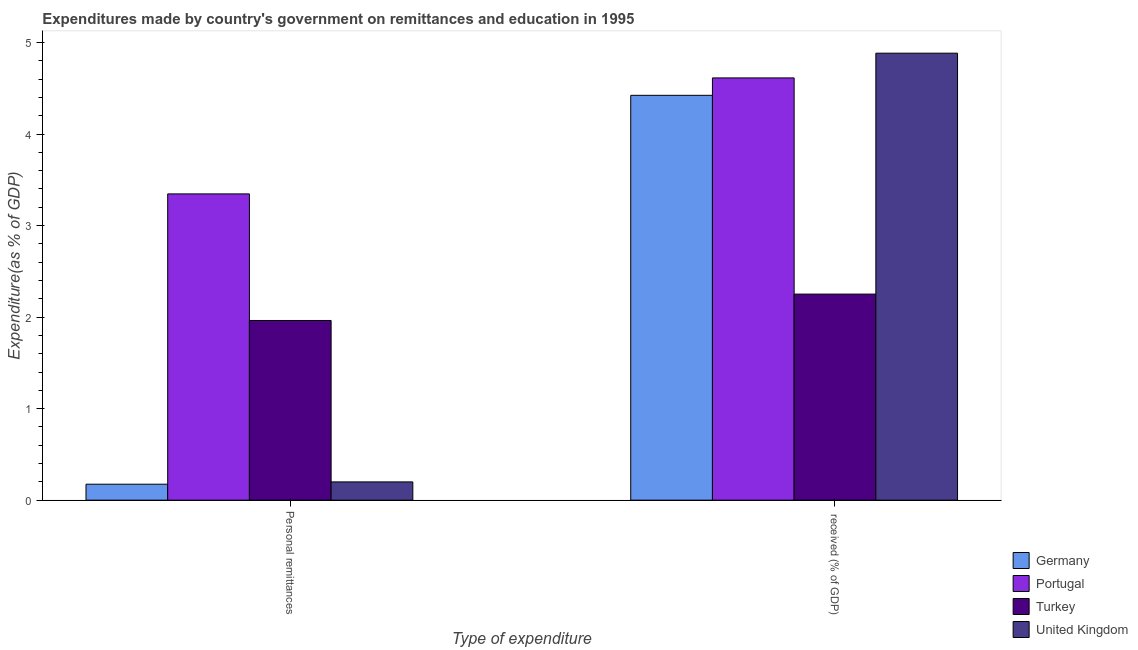Are the number of bars on each tick of the X-axis equal?
Your answer should be very brief. Yes. What is the label of the 1st group of bars from the left?
Provide a short and direct response. Personal remittances. What is the expenditure in education in Portugal?
Ensure brevity in your answer.  4.61. Across all countries, what is the maximum expenditure in personal remittances?
Your answer should be compact. 3.35. Across all countries, what is the minimum expenditure in education?
Offer a terse response. 2.25. What is the total expenditure in education in the graph?
Your answer should be compact. 16.17. What is the difference between the expenditure in personal remittances in Portugal and that in Turkey?
Ensure brevity in your answer.  1.38. What is the difference between the expenditure in education in Portugal and the expenditure in personal remittances in Turkey?
Offer a terse response. 2.65. What is the average expenditure in personal remittances per country?
Offer a very short reply. 1.42. What is the difference between the expenditure in personal remittances and expenditure in education in United Kingdom?
Offer a terse response. -4.68. What is the ratio of the expenditure in personal remittances in Portugal to that in Germany?
Your response must be concise. 19.17. Is the expenditure in education in Germany less than that in United Kingdom?
Provide a succinct answer. Yes. In how many countries, is the expenditure in education greater than the average expenditure in education taken over all countries?
Your answer should be compact. 3. What does the 1st bar from the left in  received (% of GDP) represents?
Give a very brief answer. Germany. Does the graph contain any zero values?
Provide a short and direct response. No. Does the graph contain grids?
Keep it short and to the point. No. How many legend labels are there?
Your answer should be very brief. 4. How are the legend labels stacked?
Your response must be concise. Vertical. What is the title of the graph?
Keep it short and to the point. Expenditures made by country's government on remittances and education in 1995. What is the label or title of the X-axis?
Provide a short and direct response. Type of expenditure. What is the label or title of the Y-axis?
Make the answer very short. Expenditure(as % of GDP). What is the Expenditure(as % of GDP) of Germany in Personal remittances?
Give a very brief answer. 0.17. What is the Expenditure(as % of GDP) in Portugal in Personal remittances?
Your answer should be very brief. 3.35. What is the Expenditure(as % of GDP) of Turkey in Personal remittances?
Keep it short and to the point. 1.96. What is the Expenditure(as % of GDP) of United Kingdom in Personal remittances?
Your response must be concise. 0.2. What is the Expenditure(as % of GDP) of Germany in  received (% of GDP)?
Make the answer very short. 4.42. What is the Expenditure(as % of GDP) of Portugal in  received (% of GDP)?
Your answer should be compact. 4.61. What is the Expenditure(as % of GDP) in Turkey in  received (% of GDP)?
Your answer should be compact. 2.25. What is the Expenditure(as % of GDP) of United Kingdom in  received (% of GDP)?
Keep it short and to the point. 4.88. Across all Type of expenditure, what is the maximum Expenditure(as % of GDP) in Germany?
Your answer should be very brief. 4.42. Across all Type of expenditure, what is the maximum Expenditure(as % of GDP) of Portugal?
Offer a very short reply. 4.61. Across all Type of expenditure, what is the maximum Expenditure(as % of GDP) in Turkey?
Provide a short and direct response. 2.25. Across all Type of expenditure, what is the maximum Expenditure(as % of GDP) in United Kingdom?
Offer a terse response. 4.88. Across all Type of expenditure, what is the minimum Expenditure(as % of GDP) of Germany?
Offer a terse response. 0.17. Across all Type of expenditure, what is the minimum Expenditure(as % of GDP) in Portugal?
Ensure brevity in your answer.  3.35. Across all Type of expenditure, what is the minimum Expenditure(as % of GDP) of Turkey?
Make the answer very short. 1.96. Across all Type of expenditure, what is the minimum Expenditure(as % of GDP) of United Kingdom?
Ensure brevity in your answer.  0.2. What is the total Expenditure(as % of GDP) of Germany in the graph?
Provide a succinct answer. 4.6. What is the total Expenditure(as % of GDP) of Portugal in the graph?
Ensure brevity in your answer.  7.96. What is the total Expenditure(as % of GDP) of Turkey in the graph?
Give a very brief answer. 4.21. What is the total Expenditure(as % of GDP) in United Kingdom in the graph?
Give a very brief answer. 5.08. What is the difference between the Expenditure(as % of GDP) in Germany in Personal remittances and that in  received (% of GDP)?
Provide a short and direct response. -4.25. What is the difference between the Expenditure(as % of GDP) of Portugal in Personal remittances and that in  received (% of GDP)?
Keep it short and to the point. -1.27. What is the difference between the Expenditure(as % of GDP) of Turkey in Personal remittances and that in  received (% of GDP)?
Give a very brief answer. -0.29. What is the difference between the Expenditure(as % of GDP) in United Kingdom in Personal remittances and that in  received (% of GDP)?
Offer a terse response. -4.68. What is the difference between the Expenditure(as % of GDP) in Germany in Personal remittances and the Expenditure(as % of GDP) in Portugal in  received (% of GDP)?
Provide a short and direct response. -4.44. What is the difference between the Expenditure(as % of GDP) in Germany in Personal remittances and the Expenditure(as % of GDP) in Turkey in  received (% of GDP)?
Your answer should be very brief. -2.08. What is the difference between the Expenditure(as % of GDP) in Germany in Personal remittances and the Expenditure(as % of GDP) in United Kingdom in  received (% of GDP)?
Your response must be concise. -4.71. What is the difference between the Expenditure(as % of GDP) in Portugal in Personal remittances and the Expenditure(as % of GDP) in Turkey in  received (% of GDP)?
Make the answer very short. 1.09. What is the difference between the Expenditure(as % of GDP) of Portugal in Personal remittances and the Expenditure(as % of GDP) of United Kingdom in  received (% of GDP)?
Your response must be concise. -1.54. What is the difference between the Expenditure(as % of GDP) in Turkey in Personal remittances and the Expenditure(as % of GDP) in United Kingdom in  received (% of GDP)?
Provide a short and direct response. -2.92. What is the average Expenditure(as % of GDP) in Germany per Type of expenditure?
Your response must be concise. 2.3. What is the average Expenditure(as % of GDP) in Portugal per Type of expenditure?
Provide a succinct answer. 3.98. What is the average Expenditure(as % of GDP) in Turkey per Type of expenditure?
Make the answer very short. 2.11. What is the average Expenditure(as % of GDP) of United Kingdom per Type of expenditure?
Offer a terse response. 2.54. What is the difference between the Expenditure(as % of GDP) in Germany and Expenditure(as % of GDP) in Portugal in Personal remittances?
Offer a very short reply. -3.17. What is the difference between the Expenditure(as % of GDP) of Germany and Expenditure(as % of GDP) of Turkey in Personal remittances?
Your answer should be very brief. -1.79. What is the difference between the Expenditure(as % of GDP) of Germany and Expenditure(as % of GDP) of United Kingdom in Personal remittances?
Offer a terse response. -0.03. What is the difference between the Expenditure(as % of GDP) in Portugal and Expenditure(as % of GDP) in Turkey in Personal remittances?
Provide a succinct answer. 1.38. What is the difference between the Expenditure(as % of GDP) in Portugal and Expenditure(as % of GDP) in United Kingdom in Personal remittances?
Your answer should be very brief. 3.15. What is the difference between the Expenditure(as % of GDP) of Turkey and Expenditure(as % of GDP) of United Kingdom in Personal remittances?
Your response must be concise. 1.76. What is the difference between the Expenditure(as % of GDP) of Germany and Expenditure(as % of GDP) of Portugal in  received (% of GDP)?
Offer a terse response. -0.19. What is the difference between the Expenditure(as % of GDP) in Germany and Expenditure(as % of GDP) in Turkey in  received (% of GDP)?
Offer a terse response. 2.17. What is the difference between the Expenditure(as % of GDP) in Germany and Expenditure(as % of GDP) in United Kingdom in  received (% of GDP)?
Your answer should be compact. -0.46. What is the difference between the Expenditure(as % of GDP) of Portugal and Expenditure(as % of GDP) of Turkey in  received (% of GDP)?
Provide a short and direct response. 2.36. What is the difference between the Expenditure(as % of GDP) in Portugal and Expenditure(as % of GDP) in United Kingdom in  received (% of GDP)?
Your answer should be very brief. -0.27. What is the difference between the Expenditure(as % of GDP) of Turkey and Expenditure(as % of GDP) of United Kingdom in  received (% of GDP)?
Keep it short and to the point. -2.63. What is the ratio of the Expenditure(as % of GDP) of Germany in Personal remittances to that in  received (% of GDP)?
Give a very brief answer. 0.04. What is the ratio of the Expenditure(as % of GDP) of Portugal in Personal remittances to that in  received (% of GDP)?
Ensure brevity in your answer.  0.73. What is the ratio of the Expenditure(as % of GDP) of Turkey in Personal remittances to that in  received (% of GDP)?
Offer a very short reply. 0.87. What is the ratio of the Expenditure(as % of GDP) in United Kingdom in Personal remittances to that in  received (% of GDP)?
Provide a short and direct response. 0.04. What is the difference between the highest and the second highest Expenditure(as % of GDP) of Germany?
Ensure brevity in your answer.  4.25. What is the difference between the highest and the second highest Expenditure(as % of GDP) of Portugal?
Ensure brevity in your answer.  1.27. What is the difference between the highest and the second highest Expenditure(as % of GDP) of Turkey?
Give a very brief answer. 0.29. What is the difference between the highest and the second highest Expenditure(as % of GDP) in United Kingdom?
Your answer should be compact. 4.68. What is the difference between the highest and the lowest Expenditure(as % of GDP) of Germany?
Make the answer very short. 4.25. What is the difference between the highest and the lowest Expenditure(as % of GDP) in Portugal?
Provide a short and direct response. 1.27. What is the difference between the highest and the lowest Expenditure(as % of GDP) in Turkey?
Your answer should be very brief. 0.29. What is the difference between the highest and the lowest Expenditure(as % of GDP) of United Kingdom?
Give a very brief answer. 4.68. 